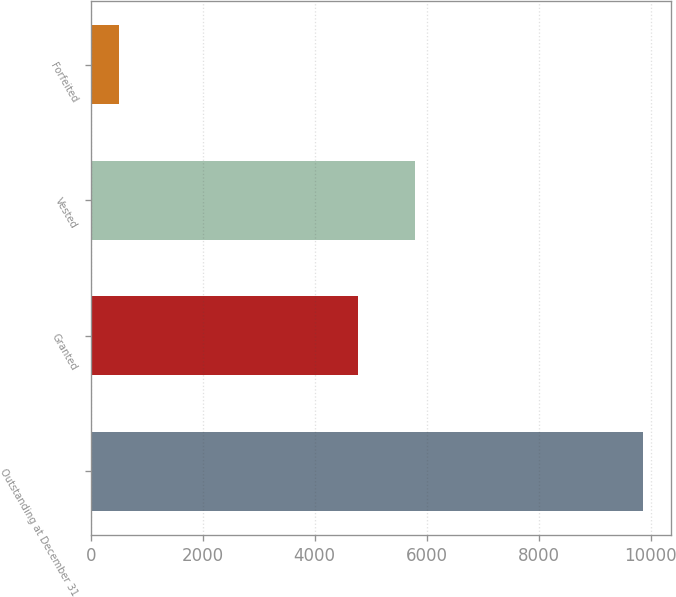Convert chart. <chart><loc_0><loc_0><loc_500><loc_500><bar_chart><fcel>Outstanding at December 31<fcel>Granted<fcel>Vested<fcel>Forfeited<nl><fcel>9868<fcel>4771<fcel>5788<fcel>512<nl></chart> 